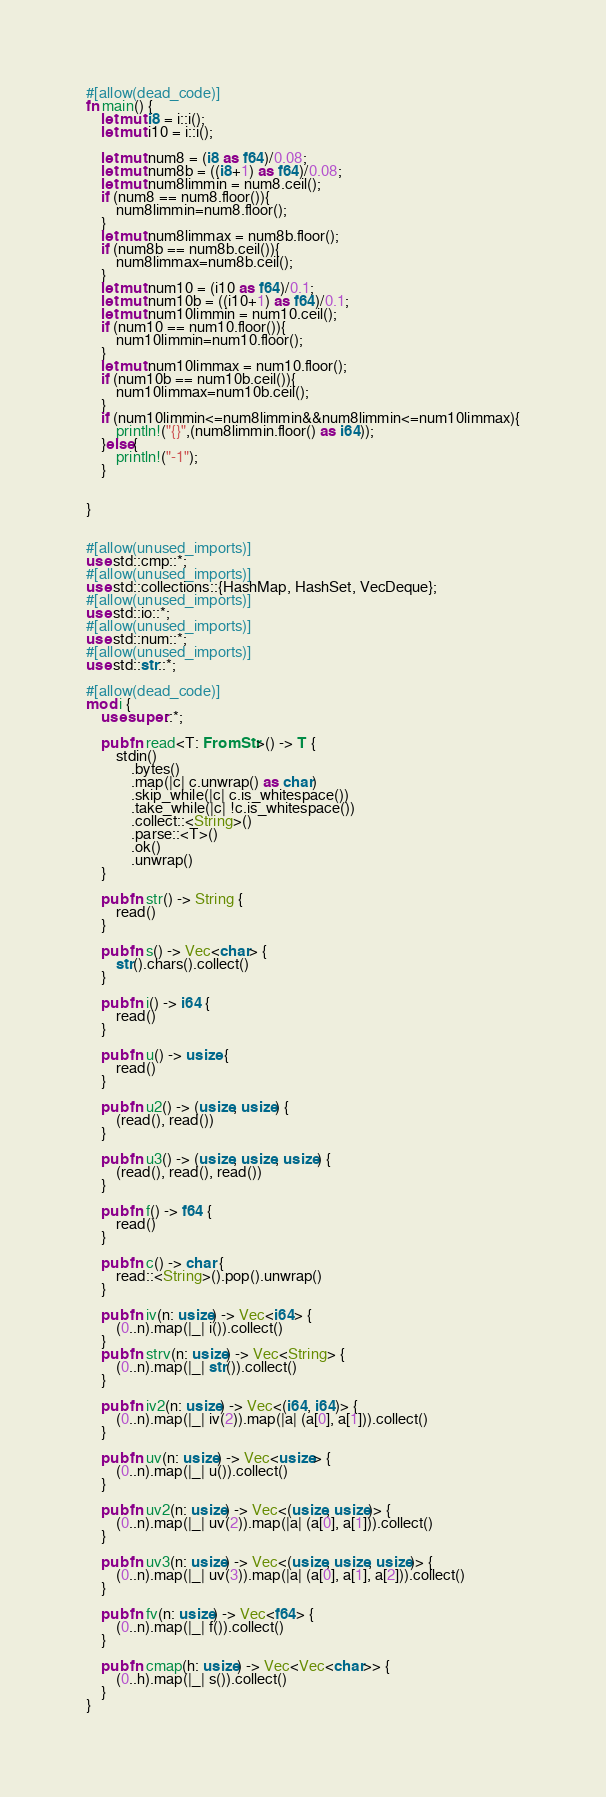<code> <loc_0><loc_0><loc_500><loc_500><_Rust_>#[allow(dead_code)]
fn main() {
    let mut i8 = i::i();
    let mut i10 = i::i();

    let mut num8 = (i8 as f64)/0.08;
    let mut num8b = ((i8+1) as f64)/0.08;
    let mut num8limmin = num8.ceil();
    if (num8 == num8.floor()){
        num8limmin=num8.floor();
    }
    let mut num8limmax = num8b.floor();
    if (num8b == num8b.ceil()){
        num8limmax=num8b.ceil();
    }
    let mut num10 = (i10 as f64)/0.1;
    let mut num10b = ((i10+1) as f64)/0.1;
    let mut num10limmin = num10.ceil();
    if (num10 == num10.floor()){
        num10limmin=num10.floor();
    }
    let mut num10limmax = num10.floor();
    if (num10b == num10b.ceil()){
        num10limmax=num10b.ceil();
    }
    if (num10limmin<=num8limmin&&num8limmin<=num10limmax){
        println!("{}",(num8limmin.floor() as i64));
    }else{
        println!("-1");
    }


}


#[allow(unused_imports)]
use std::cmp::*;
#[allow(unused_imports)]
use std::collections::{HashMap, HashSet, VecDeque};
#[allow(unused_imports)]
use std::io::*;
#[allow(unused_imports)]
use std::num::*;
#[allow(unused_imports)]
use std::str::*;

#[allow(dead_code)]
mod i {
    use super::*;

    pub fn read<T: FromStr>() -> T {
        stdin()
            .bytes()
            .map(|c| c.unwrap() as char)
            .skip_while(|c| c.is_whitespace())
            .take_while(|c| !c.is_whitespace())
            .collect::<String>()
            .parse::<T>()
            .ok()
            .unwrap()
    }

    pub fn str() -> String {
        read()
    }

    pub fn s() -> Vec<char> {
        str().chars().collect()
    }

    pub fn i() -> i64 {
        read()
    }

    pub fn u() -> usize {
        read()
    }

    pub fn u2() -> (usize, usize) {
        (read(), read())
    }

    pub fn u3() -> (usize, usize, usize) {
        (read(), read(), read())
    }

    pub fn f() -> f64 {
        read()
    }

    pub fn c() -> char {
        read::<String>().pop().unwrap()
    }

    pub fn iv(n: usize) -> Vec<i64> {
        (0..n).map(|_| i()).collect()
    }
    pub fn strv(n: usize) -> Vec<String> {
        (0..n).map(|_| str()).collect()
    }

    pub fn iv2(n: usize) -> Vec<(i64, i64)> {
        (0..n).map(|_| iv(2)).map(|a| (a[0], a[1])).collect()
    }

    pub fn uv(n: usize) -> Vec<usize> {
        (0..n).map(|_| u()).collect()
    }

    pub fn uv2(n: usize) -> Vec<(usize, usize)> {
        (0..n).map(|_| uv(2)).map(|a| (a[0], a[1])).collect()
    }

    pub fn uv3(n: usize) -> Vec<(usize, usize, usize)> {
        (0..n).map(|_| uv(3)).map(|a| (a[0], a[1], a[2])).collect()
    }

    pub fn fv(n: usize) -> Vec<f64> {
        (0..n).map(|_| f()).collect()
    }

    pub fn cmap(h: usize) -> Vec<Vec<char>> {
        (0..h).map(|_| s()).collect()
    }
}
</code> 